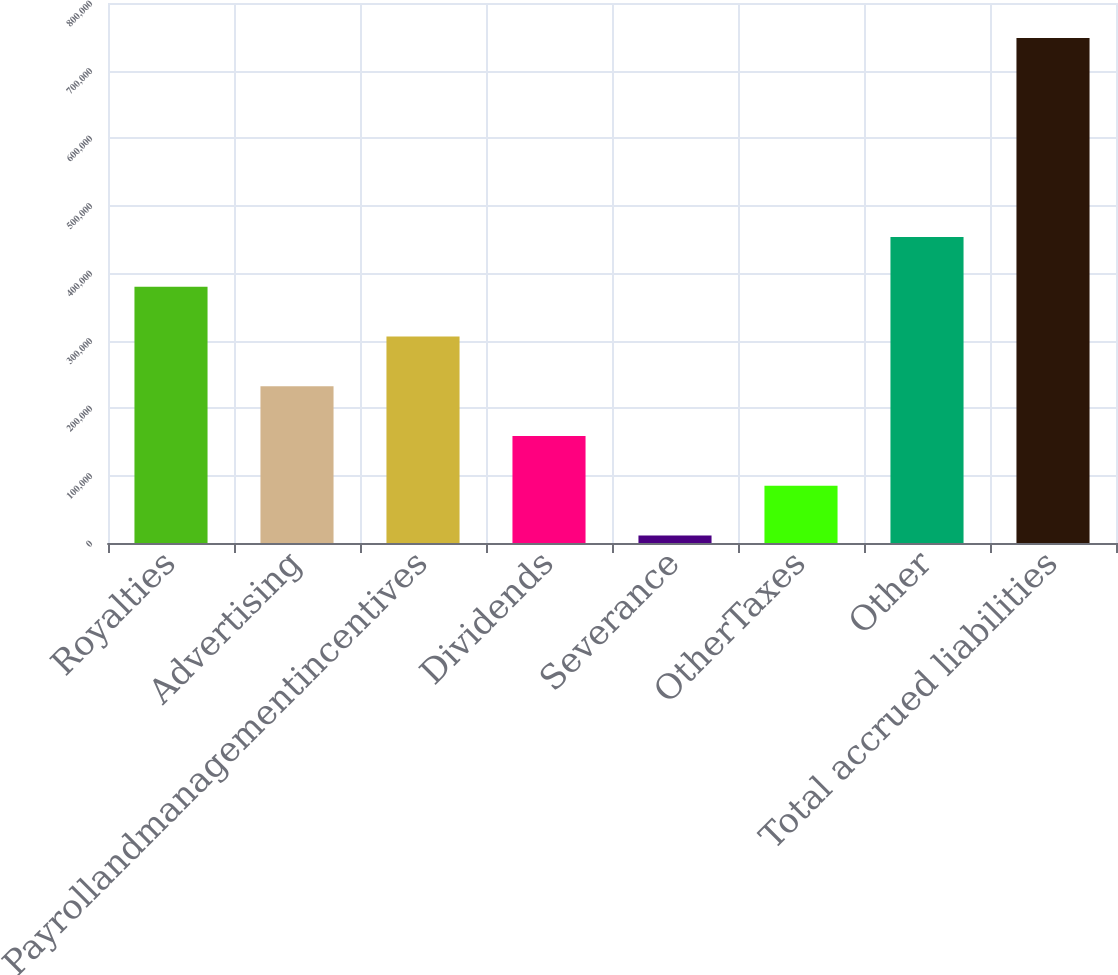Convert chart. <chart><loc_0><loc_0><loc_500><loc_500><bar_chart><fcel>Royalties<fcel>Advertising<fcel>Payrollandmanagementincentives<fcel>Dividends<fcel>Severance<fcel>OtherTaxes<fcel>Other<fcel>Total accrued liabilities<nl><fcel>379608<fcel>232146<fcel>305877<fcel>158414<fcel>10952<fcel>84683.2<fcel>453339<fcel>748264<nl></chart> 